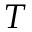<formula> <loc_0><loc_0><loc_500><loc_500>T</formula> 